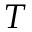<formula> <loc_0><loc_0><loc_500><loc_500>T</formula> 